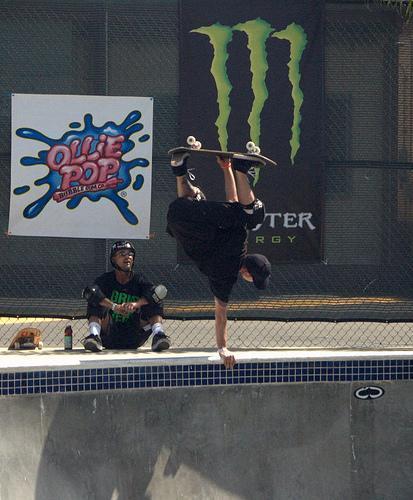How many people are in this picture?
Give a very brief answer. 2. 